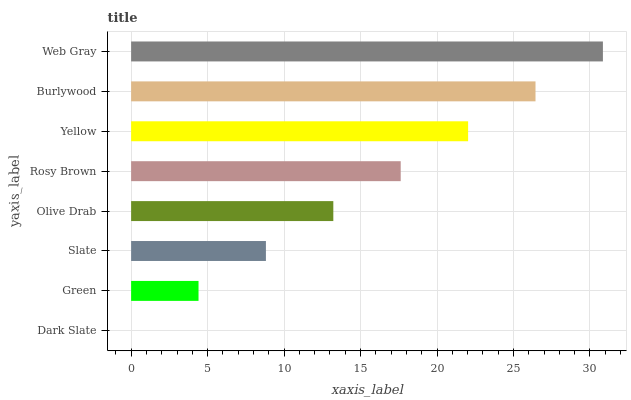Is Dark Slate the minimum?
Answer yes or no. Yes. Is Web Gray the maximum?
Answer yes or no. Yes. Is Green the minimum?
Answer yes or no. No. Is Green the maximum?
Answer yes or no. No. Is Green greater than Dark Slate?
Answer yes or no. Yes. Is Dark Slate less than Green?
Answer yes or no. Yes. Is Dark Slate greater than Green?
Answer yes or no. No. Is Green less than Dark Slate?
Answer yes or no. No. Is Rosy Brown the high median?
Answer yes or no. Yes. Is Olive Drab the low median?
Answer yes or no. Yes. Is Burlywood the high median?
Answer yes or no. No. Is Slate the low median?
Answer yes or no. No. 